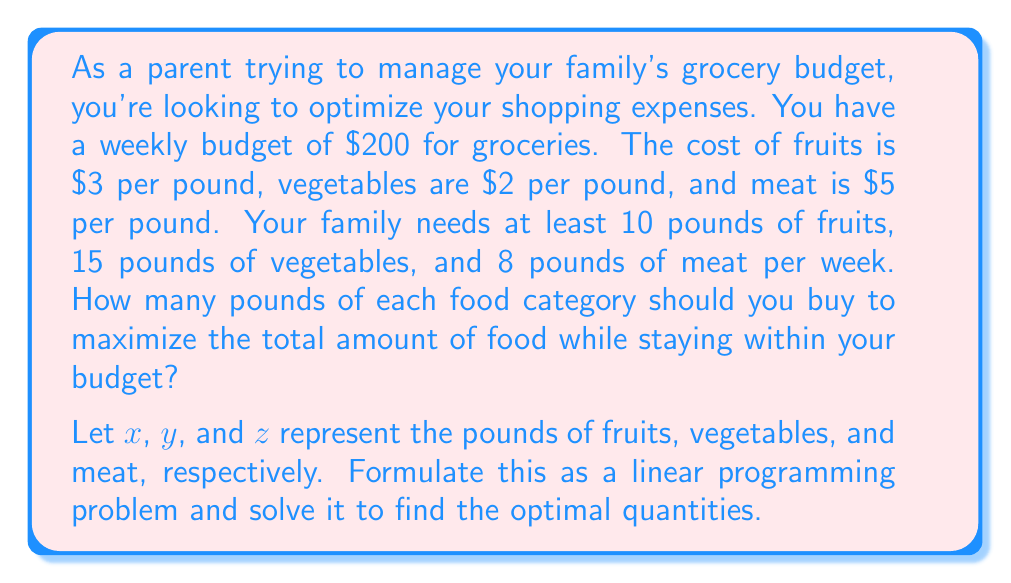Show me your answer to this math problem. Let's approach this step-by-step:

1) First, we need to set up our objective function. We want to maximize the total amount of food:
   $$ \text{Maximize: } f(x,y,z) = x + y + z $$

2) Now, let's define our constraints:
   a) Budget constraint: $3x + 2y + 5z \leq 200$
   b) Minimum requirements: $x \geq 10$, $y \geq 15$, $z \geq 8$

3) Our linear programming problem is now:
   $$ \text{Maximize: } f(x,y,z) = x + y + z $$
   $$ \text{Subject to:} $$
   $$ 3x + 2y + 5z \leq 200 $$
   $$ x \geq 10 $$
   $$ y \geq 15 $$
   $$ z \geq 8 $$

4) We can solve this using the simplex method or graphically. Let's use the graphical method.

5) First, let's consider the equality in the budget constraint:
   $$ 3x + 2y + 5z = 200 $$

6) We need to find the vertices of the feasible region. These occur where the constraints intersect:
   a) $(10, 15, 8)$ - minimum requirements for all
   b) $(10, 15, 31)$ - minimum fruits and vegetables, maximum meat
   c) $(10, 70, 8)$ - minimum fruits and meat, maximum vegetables
   d) $(46.67, 15, 8)$ - minimum vegetables and meat, maximum fruits

7) Evaluating our objective function at these points:
   a) $f(10, 15, 8) = 33$
   b) $f(10, 15, 31) = 56$
   c) $f(10, 70, 8) = 88$
   d) $f(46.67, 15, 8) = 69.67$

8) The maximum value occurs at point c, where $x = 10$, $y = 70$, and $z = 8$.

Therefore, to maximize the total amount of food while staying within the budget, you should buy 10 pounds of fruits, 70 pounds of vegetables, and 8 pounds of meat.
Answer: 10 lbs fruits, 70 lbs vegetables, 8 lbs meat 